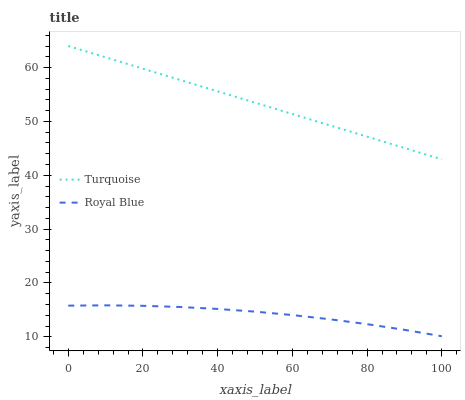Does Turquoise have the minimum area under the curve?
Answer yes or no. No. Is Turquoise the roughest?
Answer yes or no. No. Does Turquoise have the lowest value?
Answer yes or no. No. Is Royal Blue less than Turquoise?
Answer yes or no. Yes. Is Turquoise greater than Royal Blue?
Answer yes or no. Yes. Does Royal Blue intersect Turquoise?
Answer yes or no. No. 